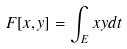<formula> <loc_0><loc_0><loc_500><loc_500>F [ x , y ] = \int _ { E } x y d t</formula> 